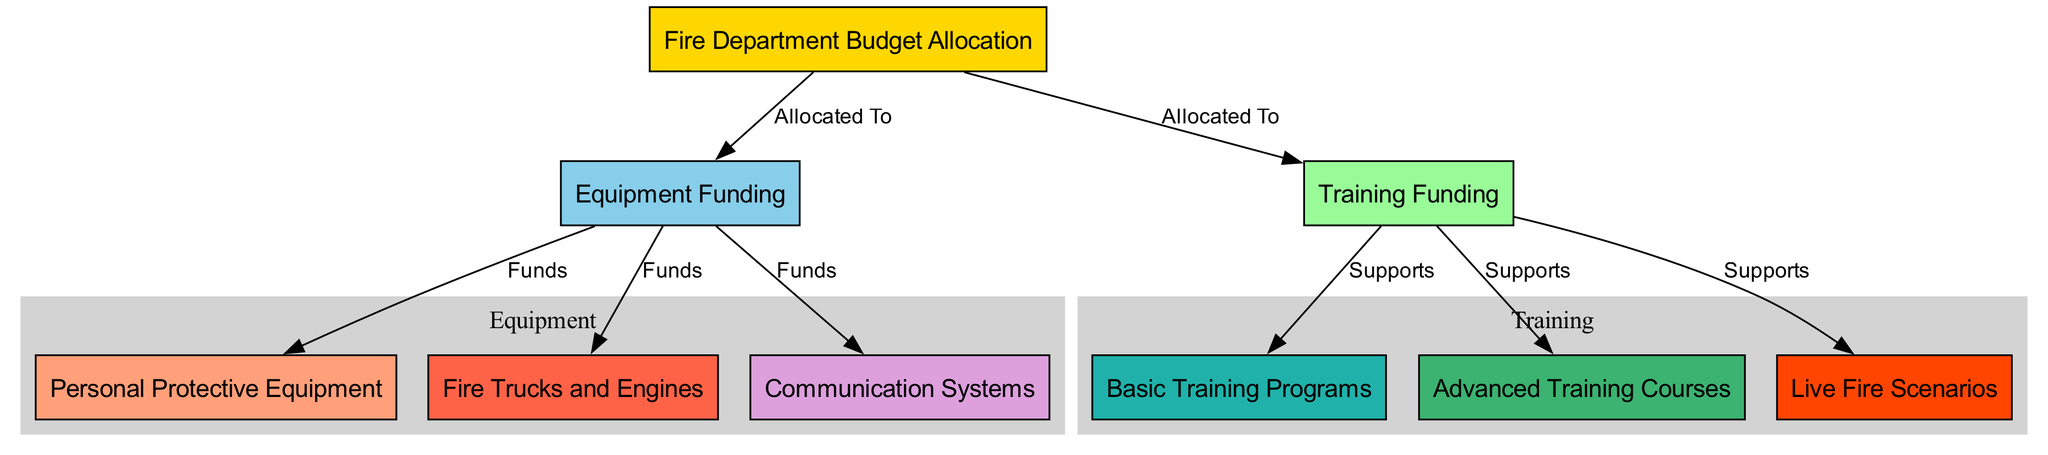What are the two main categories into which the Fire Department budget is allocated? The diagram shows two main categories connected to the central node "Fire Department Budget Allocation": "Equipment Funding" and "Training Funding".
Answer: Equipment Funding, Training Funding How many edges are there in the diagram? The diagram displays a total of 8 edges connecting the various nodes. Counting each connection shows this clearly.
Answer: 8 What type of training is supported under Training Funding? The diagram indicates three types of training that are supported under "Training Funding": "Basic Training Programs", "Advanced Training Courses", and "Live Fire Scenarios".
Answer: Basic Training Programs, Advanced Training Courses, Live Fire Scenarios Which node is directly connected to Equipment Funding and represents safety gear for firefighters? The node labeled "Personal Protective Equipment" is directly connected to "Equipment Funding", indicating it is part of the funding allocation for firefighter safety gear.
Answer: Personal Protective Equipment What are the three components funded by Equipment Funding? The diagram shows three components: "Personal Protective Equipment", "Fire Trucks and Engines", and "Communication Systems", all connected to "Equipment Funding".
Answer: Personal Protective Equipment, Fire Trucks and Engines, Communication Systems Which training programs might be necessary for advanced firefighting situations? The diagram illustrates that "Advanced Training Courses" and "Live Fire Scenarios" are necessary for advanced firefighting, being directly supported by "Training Funding".
Answer: Advanced Training Courses, Live Fire Scenarios What is the relationship between "Training Funding" and "Live Fire Scenarios"? "Training Funding" directly supports "Live Fire Scenarios", indicating a financial allocation aimed at preparing firefighters for real-life situations involving fire.
Answer: Supports How many nodes are related to equipment? In the diagram, three specific nodes are related to equipment under "Equipment Funding": "Personal Protective Equipment", "Fire Trucks and Engines", and "Communication Systems". Counting these gives a total of three.
Answer: 3 